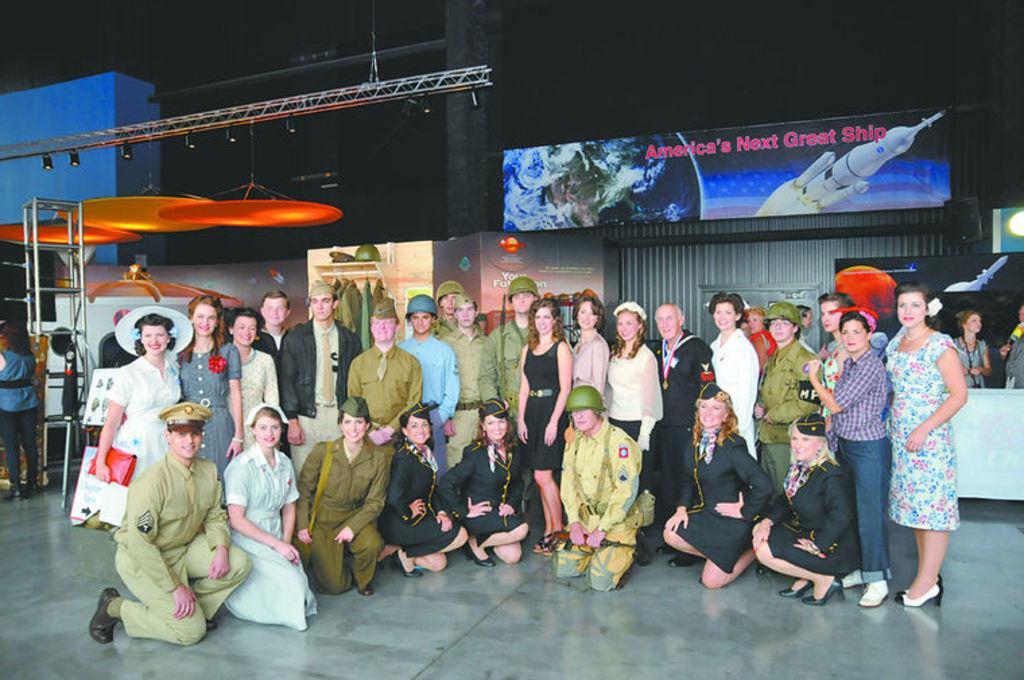Can you describe this image briefly? In this image there are group of people visible on the floor, behind them there are hoarding boards, clothes hanging to the hanger, on the right side there are two people visible in front of the table, there is a stand, person on the left side, some other objects visible at the top. 